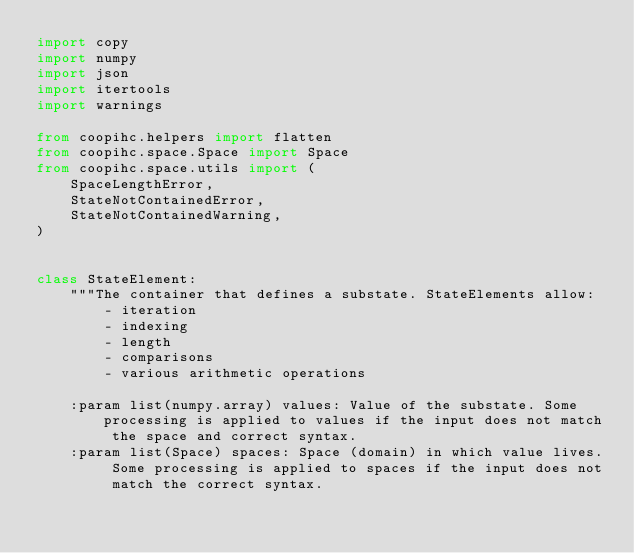<code> <loc_0><loc_0><loc_500><loc_500><_Python_>import copy
import numpy
import json
import itertools
import warnings

from coopihc.helpers import flatten
from coopihc.space.Space import Space
from coopihc.space.utils import (
    SpaceLengthError,
    StateNotContainedError,
    StateNotContainedWarning,
)


class StateElement:
    """The container that defines a substate. StateElements allow:
        - iteration
        - indexing
        - length
        - comparisons
        - various arithmetic operations

    :param list(numpy.array) values: Value of the substate. Some processing is applied to values if the input does not match the space and correct syntax.
    :param list(Space) spaces: Space (domain) in which value lives. Some processing is applied to spaces if the input does not match the correct syntax.</code> 